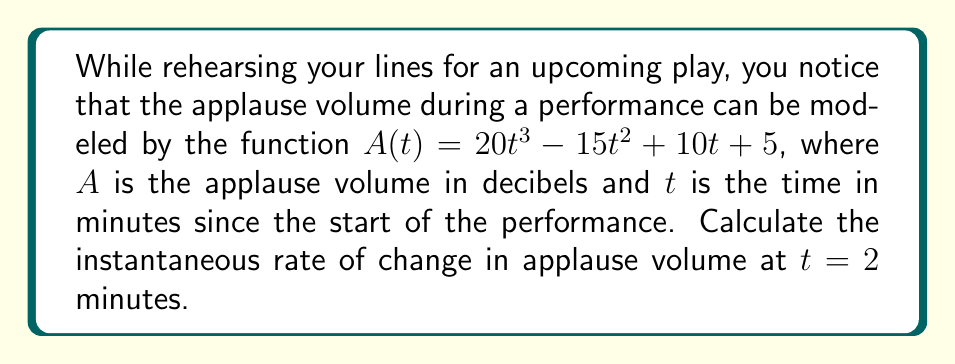Can you solve this math problem? To find the instantaneous rate of change in applause volume at $t = 2$ minutes, we need to calculate the derivative of the function $A(t)$ and evaluate it at $t = 2$.

Step 1: Find the derivative of $A(t)$.
$$A(t) = 20t^3 - 15t^2 + 10t + 5$$
$$A'(t) = 60t^2 - 30t + 10$$

Step 2: Evaluate $A'(t)$ at $t = 2$.
$$A'(2) = 60(2)^2 - 30(2) + 10$$
$$A'(2) = 60(4) - 60 + 10$$
$$A'(2) = 240 - 60 + 10$$
$$A'(2) = 190$$

The instantaneous rate of change at $t = 2$ minutes is 190 decibels per minute.
Answer: 190 decibels per minute 